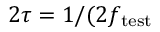<formula> <loc_0><loc_0><loc_500><loc_500>2 \tau = 1 / ( 2 f _ { t e s t }</formula> 